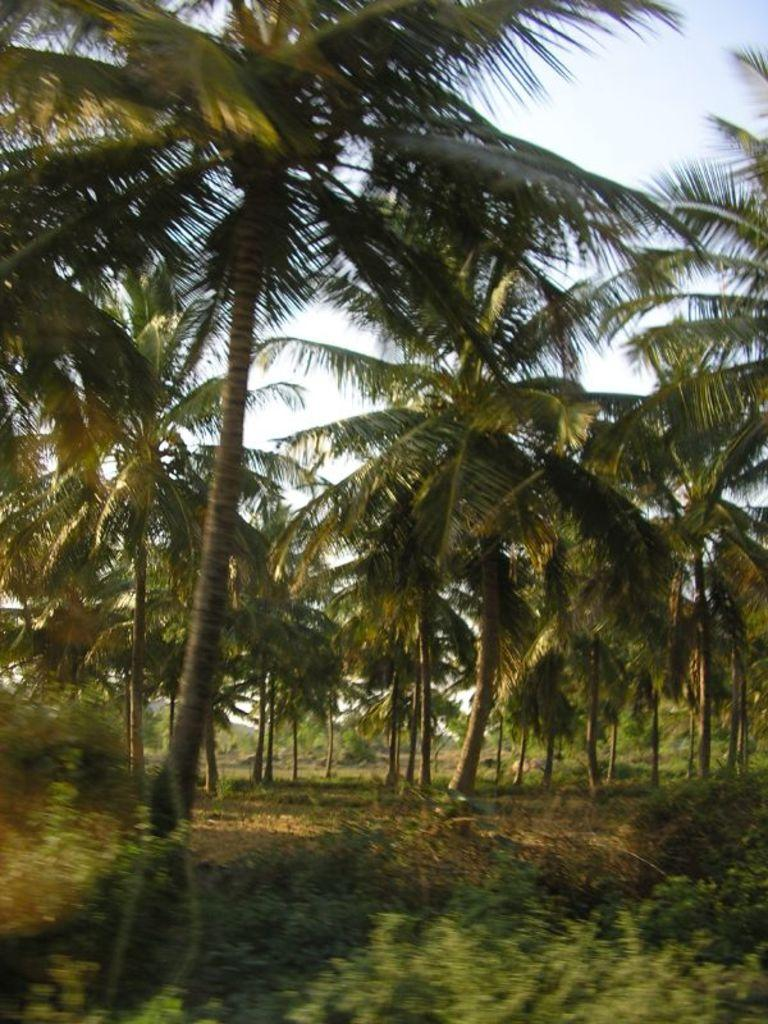What is the main feature in the center of the image? There are trees in the center of the image. What type of vegetation is present on the ground? There is grass on the ground. How would you describe the sky in the image? The sky is cloudy. What type of fuel is being used by the vessel in the image? There is no vessel present in the image, so it is not possible to determine what type of fuel it might be using. 